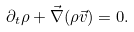Convert formula to latex. <formula><loc_0><loc_0><loc_500><loc_500>\partial _ { t } \rho + \vec { \nabla } ( \rho \vec { v } ) = 0 .</formula> 